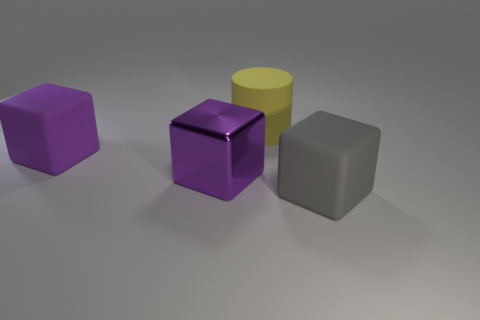There is a object that is both right of the purple rubber thing and behind the purple metal cube; what size is it? The object situated to the right of the purple rubber-like object and behind the purple metal cube appears to be a grey cube which is medium-sized compared to the other items in the image. 